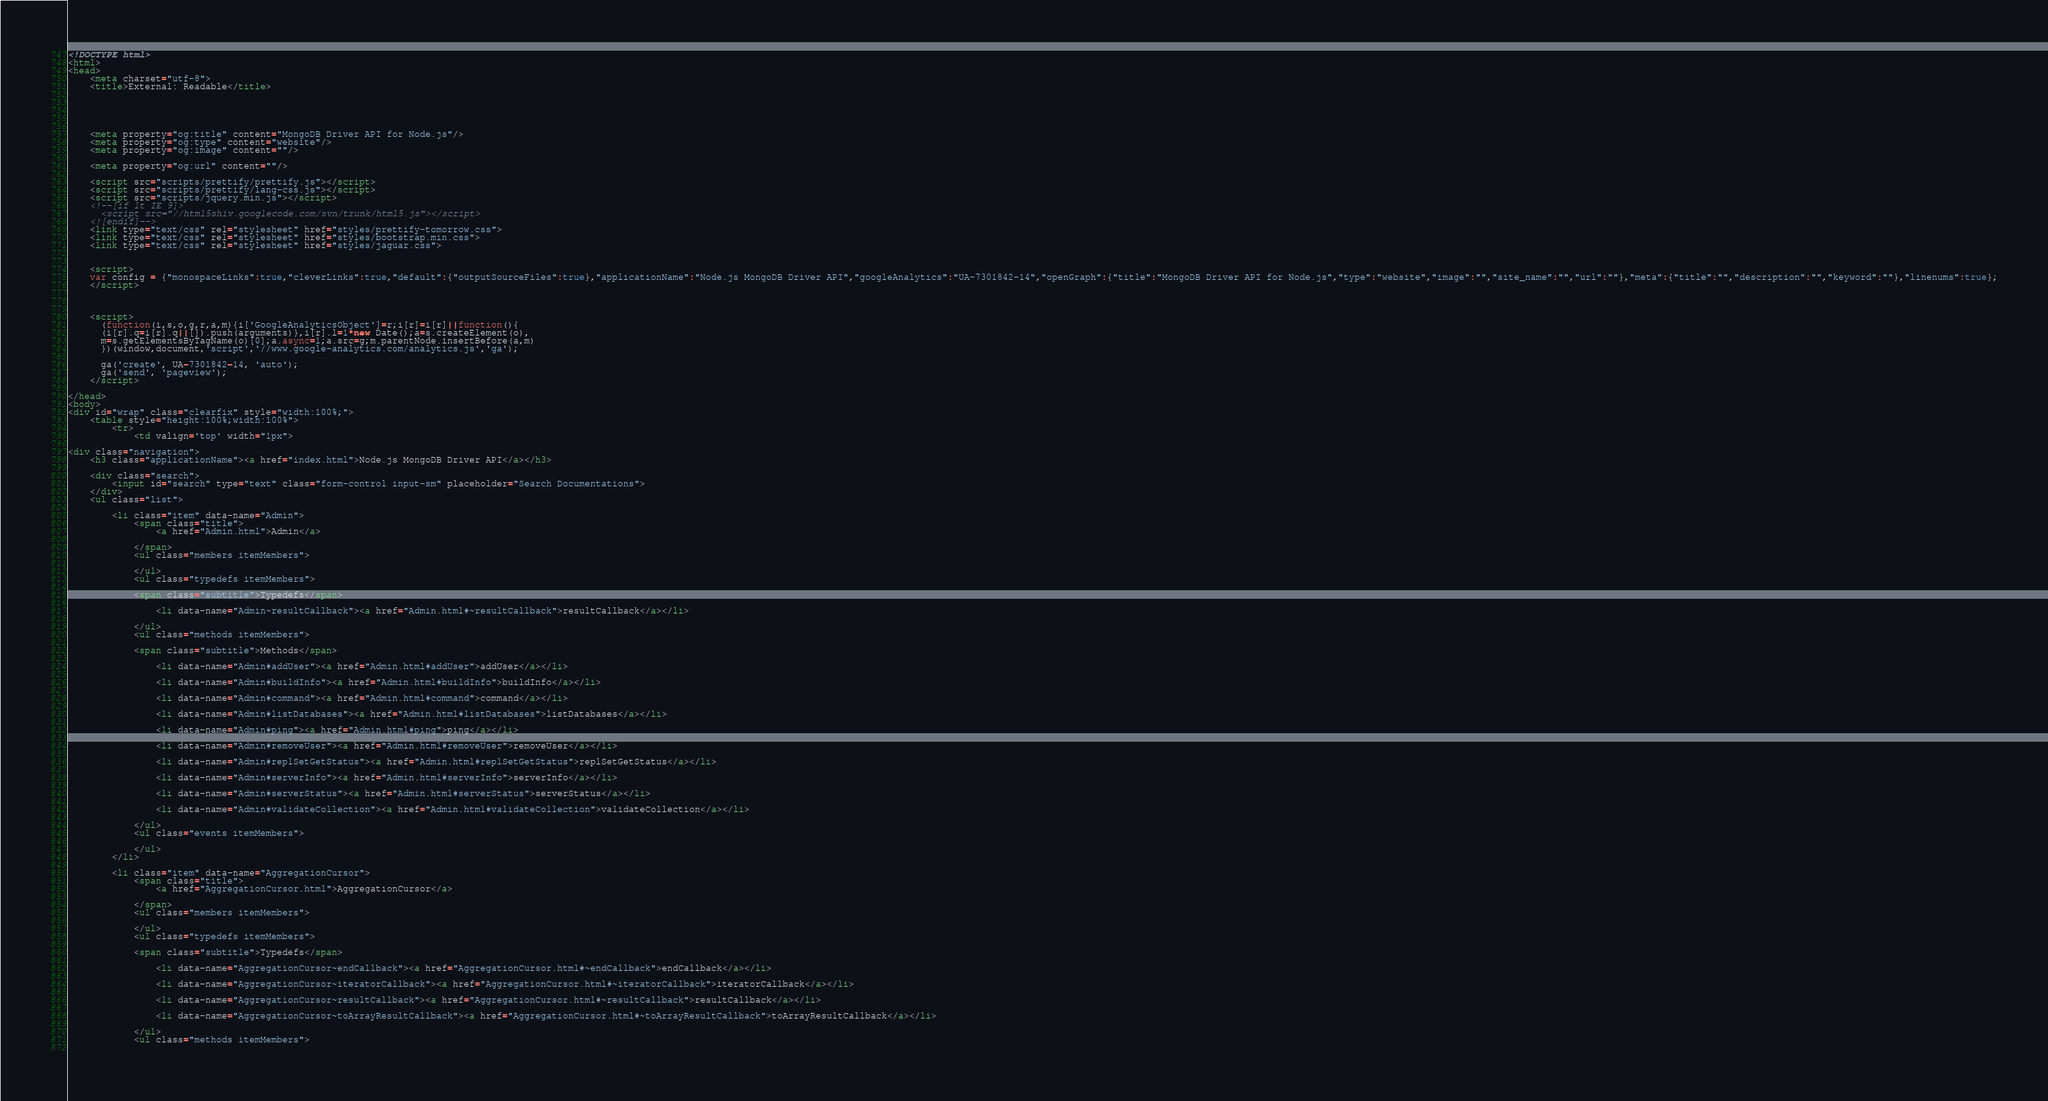<code> <loc_0><loc_0><loc_500><loc_500><_HTML_><!DOCTYPE html>
<html>
<head>
    <meta charset="utf-8">
    <title>External: Readable</title>
    
    
    
    
    
    <meta property="og:title" content="MongoDB Driver API for Node.js"/>
    <meta property="og:type" content="website"/>
    <meta property="og:image" content=""/>
    
    <meta property="og:url" content=""/>
    
    <script src="scripts/prettify/prettify.js"></script>
    <script src="scripts/prettify/lang-css.js"></script>
    <script src="scripts/jquery.min.js"></script>
    <!--[if lt IE 9]>
      <script src="//html5shiv.googlecode.com/svn/trunk/html5.js"></script>
    <![endif]-->
    <link type="text/css" rel="stylesheet" href="styles/prettify-tomorrow.css">
    <link type="text/css" rel="stylesheet" href="styles/bootstrap.min.css">
    <link type="text/css" rel="stylesheet" href="styles/jaguar.css">
    
    
    <script>
    var config = {"monospaceLinks":true,"cleverLinks":true,"default":{"outputSourceFiles":true},"applicationName":"Node.js MongoDB Driver API","googleAnalytics":"UA-7301842-14","openGraph":{"title":"MongoDB Driver API for Node.js","type":"website","image":"","site_name":"","url":""},"meta":{"title":"","description":"","keyword":""},"linenums":true};
    </script>
    

    
    <script>
      (function(i,s,o,g,r,a,m){i['GoogleAnalyticsObject']=r;i[r]=i[r]||function(){
      (i[r].q=i[r].q||[]).push(arguments)},i[r].l=1*new Date();a=s.createElement(o),
      m=s.getElementsByTagName(o)[0];a.async=1;a.src=g;m.parentNode.insertBefore(a,m)
      })(window,document,'script','//www.google-analytics.com/analytics.js','ga');

      ga('create', UA-7301842-14, 'auto');
      ga('send', 'pageview');
    </script>    
    
</head>
<body>
<div id="wrap" class="clearfix" style="width:100%;">
    <table style="height:100%;width:100%">
        <tr>
            <td valign='top' width="1px">
                
<div class="navigation">
    <h3 class="applicationName"><a href="index.html">Node.js MongoDB Driver API</a></h3>

    <div class="search">
        <input id="search" type="text" class="form-control input-sm" placeholder="Search Documentations">
    </div>
    <ul class="list">
    
        <li class="item" data-name="Admin">
            <span class="title">
                <a href="Admin.html">Admin</a>
                
            </span>
            <ul class="members itemMembers">
            
            </ul>
            <ul class="typedefs itemMembers">
            
            <span class="subtitle">Typedefs</span>
            
                <li data-name="Admin~resultCallback"><a href="Admin.html#~resultCallback">resultCallback</a></li>
            
            </ul>
            <ul class="methods itemMembers">
            
            <span class="subtitle">Methods</span>
            
                <li data-name="Admin#addUser"><a href="Admin.html#addUser">addUser</a></li>
            
                <li data-name="Admin#buildInfo"><a href="Admin.html#buildInfo">buildInfo</a></li>
            
                <li data-name="Admin#command"><a href="Admin.html#command">command</a></li>
            
                <li data-name="Admin#listDatabases"><a href="Admin.html#listDatabases">listDatabases</a></li>
            
                <li data-name="Admin#ping"><a href="Admin.html#ping">ping</a></li>
            
                <li data-name="Admin#removeUser"><a href="Admin.html#removeUser">removeUser</a></li>
            
                <li data-name="Admin#replSetGetStatus"><a href="Admin.html#replSetGetStatus">replSetGetStatus</a></li>
            
                <li data-name="Admin#serverInfo"><a href="Admin.html#serverInfo">serverInfo</a></li>
            
                <li data-name="Admin#serverStatus"><a href="Admin.html#serverStatus">serverStatus</a></li>
            
                <li data-name="Admin#validateCollection"><a href="Admin.html#validateCollection">validateCollection</a></li>
            
            </ul>
            <ul class="events itemMembers">
            
            </ul>
        </li>
    
        <li class="item" data-name="AggregationCursor">
            <span class="title">
                <a href="AggregationCursor.html">AggregationCursor</a>
                
            </span>
            <ul class="members itemMembers">
            
            </ul>
            <ul class="typedefs itemMembers">
            
            <span class="subtitle">Typedefs</span>
            
                <li data-name="AggregationCursor~endCallback"><a href="AggregationCursor.html#~endCallback">endCallback</a></li>
            
                <li data-name="AggregationCursor~iteratorCallback"><a href="AggregationCursor.html#~iteratorCallback">iteratorCallback</a></li>
            
                <li data-name="AggregationCursor~resultCallback"><a href="AggregationCursor.html#~resultCallback">resultCallback</a></li>
            
                <li data-name="AggregationCursor~toArrayResultCallback"><a href="AggregationCursor.html#~toArrayResultCallback">toArrayResultCallback</a></li>
            
            </ul>
            <ul class="methods itemMembers">
            </code> 